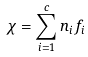Convert formula to latex. <formula><loc_0><loc_0><loc_500><loc_500>\chi = \sum _ { i = 1 } ^ { c } n _ { i } f _ { i }</formula> 